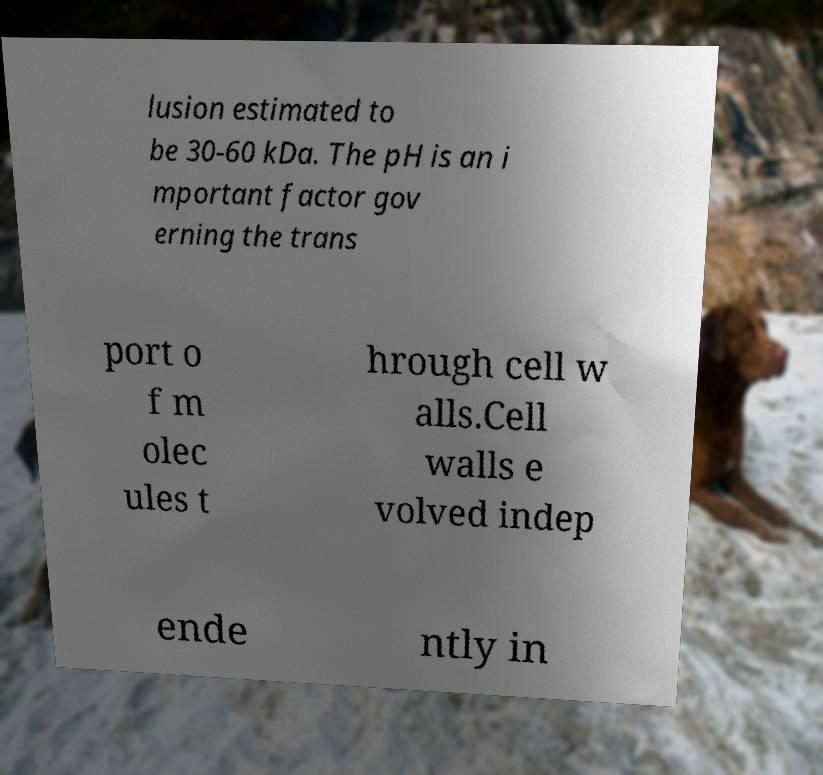There's text embedded in this image that I need extracted. Can you transcribe it verbatim? lusion estimated to be 30-60 kDa. The pH is an i mportant factor gov erning the trans port o f m olec ules t hrough cell w alls.Cell walls e volved indep ende ntly in 